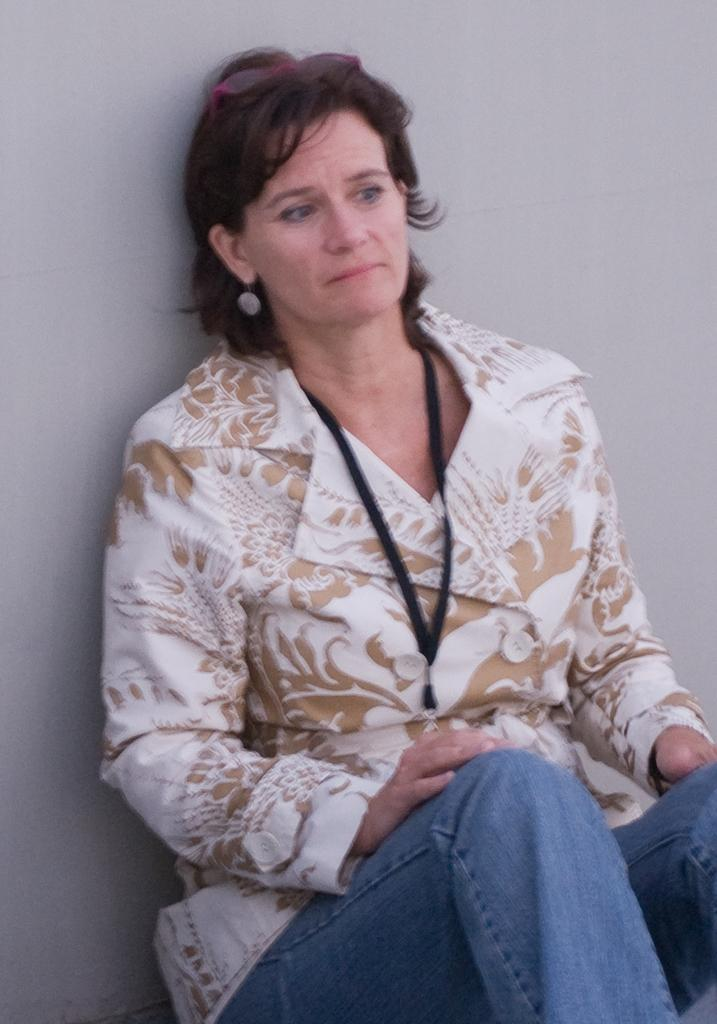Who is present in the image? There is a woman in the image. What can be seen in the background of the image? There is a wall in the background of the image. What type of quince is being served in the lunchroom in the image? There is no lunchroom or quince present in the image. 